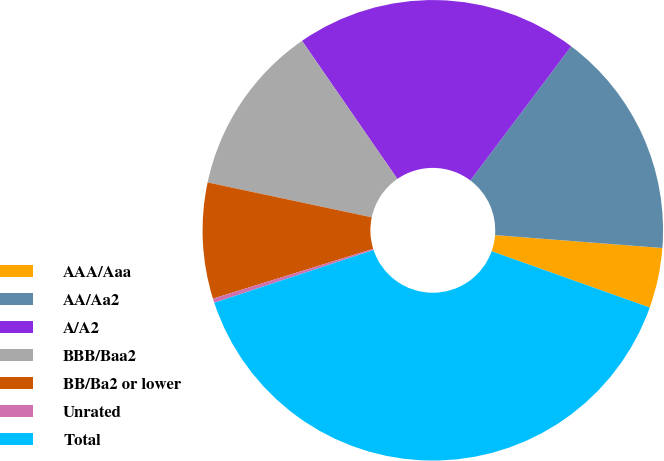<chart> <loc_0><loc_0><loc_500><loc_500><pie_chart><fcel>AAA/Aaa<fcel>AA/Aa2<fcel>A/A2<fcel>BBB/Baa2<fcel>BB/Ba2 or lower<fcel>Unrated<fcel>Total<nl><fcel>4.22%<fcel>15.96%<fcel>19.88%<fcel>12.05%<fcel>8.13%<fcel>0.3%<fcel>39.46%<nl></chart> 